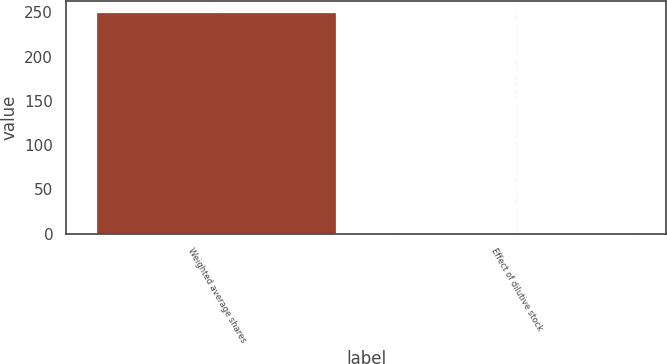<chart> <loc_0><loc_0><loc_500><loc_500><bar_chart><fcel>Weighted average shares<fcel>Effect of dilutive stock<nl><fcel>250.03<fcel>1<nl></chart> 